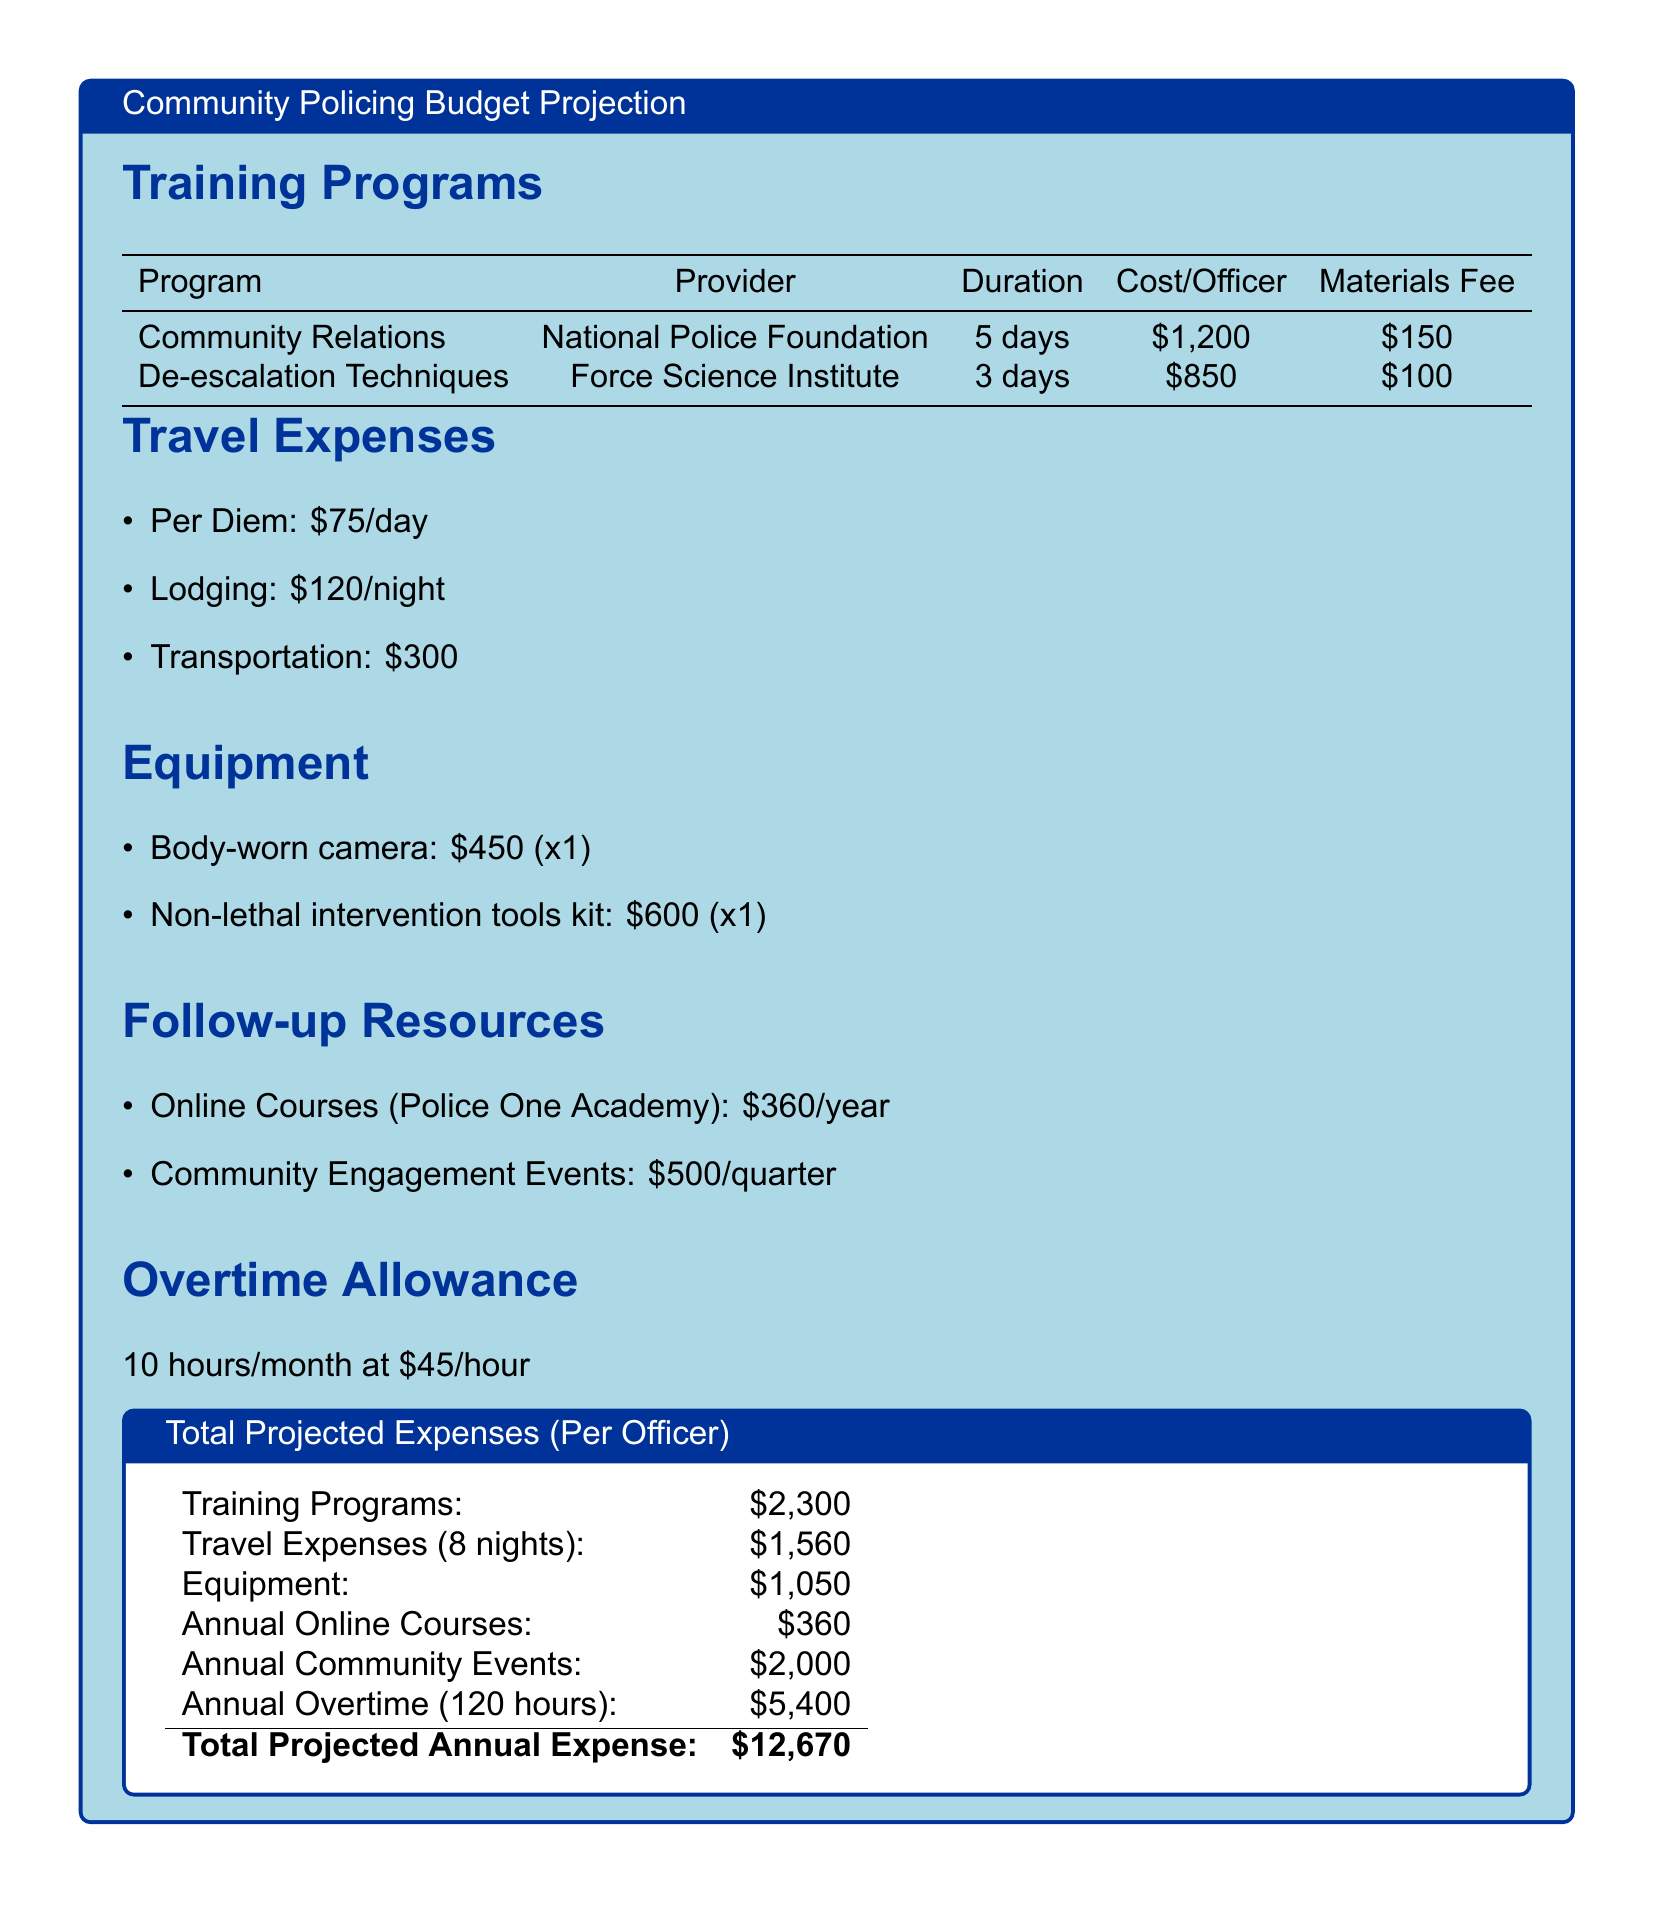What is the cost per officer for Community Relations training? The cost per officer for Community Relations training is specified in the training program section of the document.
Answer: $1,200 What is the per diem rate for travel expenses? The per diem rate is listed under travel expenses in the document.
Answer: $75/day How many days does the De-escalation Techniques training last? The duration of the De-escalation Techniques training is mentioned in the training programs section.
Answer: 3 days What is the total estimated cost for equipment? The total estimated cost for equipment is derived from the itemized costs listed under the equipment section.
Answer: $1,050 How much is the annual Community Engagement Events cost? The annual cost for Community Engagement Events is detailed in the follow-up resources section of the document.
Answer: $2,000 How many hours of overtime are budgeted annually? The number of overtime hours is indicated in the overtime allowance portion of the document.
Answer: 120 hours What is the total projected annual expense? The total projected annual expense is found at the end of the budget projection, summarizing all costs.
Answer: $12,670 Who is the provider for the Community Relations training? The provider's name is included in the training programs section.
Answer: National Police Foundation What is the materials fee for De-escalation Techniques training? The materials fee is specified in the training programs section next to the training details.
Answer: $100 